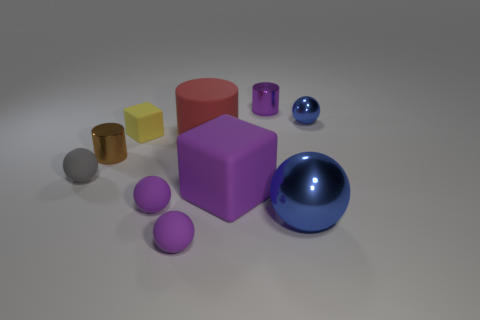Subtract all big rubber cylinders. How many cylinders are left? 2 Subtract all gray cylinders. How many blue spheres are left? 2 Subtract all blue spheres. How many spheres are left? 3 Subtract 1 cylinders. How many cylinders are left? 2 Subtract all cylinders. How many objects are left? 7 Subtract all brown balls. Subtract all red blocks. How many balls are left? 5 Add 4 large purple cubes. How many large purple cubes exist? 5 Subtract 0 blue blocks. How many objects are left? 10 Subtract all big purple rubber things. Subtract all spheres. How many objects are left? 4 Add 6 purple cylinders. How many purple cylinders are left? 7 